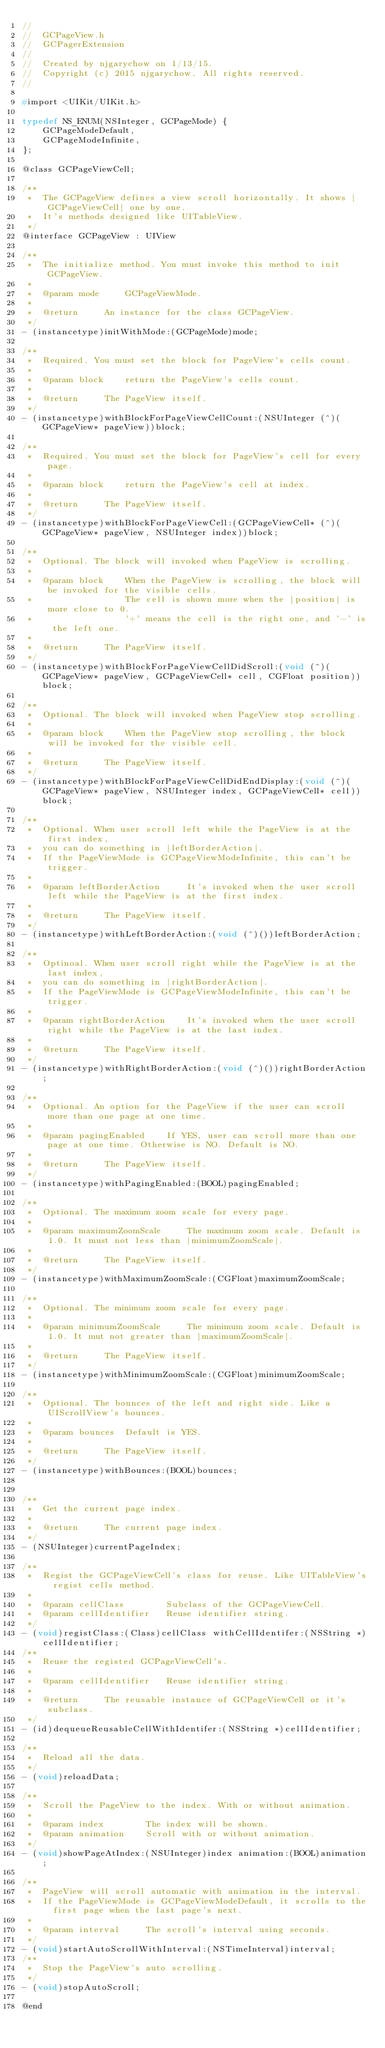<code> <loc_0><loc_0><loc_500><loc_500><_C_>//
//  GCPageView.h
//  GCPagerExtension
//
//  Created by njgarychow on 1/13/15.
//  Copyright (c) 2015 njgarychow. All rights reserved.
//

#import <UIKit/UIKit.h>

typedef NS_ENUM(NSInteger, GCPageMode) {
    GCPageModeDefault,
    GCPageModeInfinite,
};

@class GCPageViewCell;

/**
 *  The GCPageView defines a view scroll horizontally. It shows |GCPageViewCell| one by one. 
 *  It's methods designed like UITableView.
 */
@interface GCPageView : UIView

/**
 *  The initialize method. You must invoke this method to init GCPageView.
 *
 *  @param mode     GCPageViewMode.
 *
 *  @return     An instance for the class GCPageView.
 */
- (instancetype)initWithMode:(GCPageMode)mode;

/**
 *  Required. You must set the block for PageView's cells count.
 *
 *  @param block    return the PageView's cells count.
 *
 *  @return     The PageView itself.
 */
- (instancetype)withBlockForPageViewCellCount:(NSUInteger (^)(GCPageView* pageView))block;

/**
 *  Required. You must set the block for PageView's cell for every page.
 *
 *  @param block    return the PageView's cell at index.
 *
 *  @return     The PageView itself.
 */
- (instancetype)withBlockForPageViewCell:(GCPageViewCell* (^)(GCPageView* pageView, NSUInteger index))block;

/**
 *  Optional. The block will invoked when PageView is scrolling.
 *
 *  @param block    When the PageView is scrolling, the block will be invoked for the visible cells.
 *                  The cell is shown more when the |position| is more close to 0.
 *                  '+' means the cell is the right one, and '-' is the left one.
 *
 *  @return     The PageView itself.
 */
- (instancetype)withBlockForPageViewCellDidScroll:(void (^)(GCPageView* pageView, GCPageViewCell* cell, CGFloat position))block;

/**
 *  Optional. The block will invoked when PageView stop scrolling.
 *
 *  @param block    When the PageView stop scrolling, the block will be invoked for the visible cell.
 *
 *  @return     The PageView itself.
 */
- (instancetype)withBlockForPageViewCellDidEndDisplay:(void (^)(GCPageView* pageView, NSUInteger index, GCPageViewCell* cell))block;

/**
 *  Optional. When user scroll left while the PageView is at the first index, 
 *  you can do something in |leftBorderAction|. 
 *  If the PageViewMode is GCPageViewModeInfinite, this can't be trigger.
 *
 *  @param leftBorderAction     It's invoked when the user scroll left while the PageView is at the first index.
 *
 *  @return     The PageView itself.
 */
- (instancetype)withLeftBorderAction:(void (^)())leftBorderAction;

/**
 *  Optinoal. When user scroll right while the PageView is at the last index,
 *  you can do something in |rightBorderAction|.
 *  If the PageViewMode is GCPageViewModeInfinite, this can't be trigger.
 *
 *  @param rightBorderAction    It's invoked when the user scroll right while the PageView is at the last index.
 *
 *  @return     The PageView itself.
 */
- (instancetype)withRightBorderAction:(void (^)())rightBorderAction;

/**
 *  Optional. An option for the PageView if the user can scroll more than one page at one time.
 *
 *  @param pagingEnabled    If YES, user can scroll more than one page at one time. Otherwise is NO. Default is NO.
 *
 *  @return     The PageView itself.
 */
- (instancetype)withPagingEnabled:(BOOL)pagingEnabled;

/**
 *  Optional. The maximum zoom scale for every page.
 *
 *  @param maximumZoomScale     The maximum zoom scale. Default is 1.0. It must not less than |minimumZoomScale|.
 *
 *  @return     The PageView itself.
 */
- (instancetype)withMaximumZoomScale:(CGFloat)maximumZoomScale;

/**
 *  Optional. The minimum zoom scale for every page.
 *
 *  @param minimumZoomScale     The minimum zoom scale. Default is 1.0. It mut not greater than |maximumZoomScale|.
 *
 *  @return     The PageView itself.
 */
- (instancetype)withMinimumZoomScale:(CGFloat)minimumZoomScale;

/**
 *  Optional. The bounces of the left and right side. Like a UIScrollView's bounces.
 *
 *  @param bounces  Default is YES.
 *
 *  @return     The PageView itself.
 */
- (instancetype)withBounces:(BOOL)bounces;


/**
 *  Get the current page index.
 *
 *  @return     The current page index.
 */
- (NSUInteger)currentPageIndex;

/**
 *  Regist the GCPageViewCell's class for reuse. Like UITableView's regist cells method.
 *
 *  @param cellClass        Subclass of the GCPageViewCell.
 *  @param cellIdentifier   Reuse identifier string.
 */
- (void)registClass:(Class)cellClass withCellIdentifer:(NSString *)cellIdentifier;
/**
 *  Reuse the registed GCPageViewCell's.
 *
 *  @param cellIdentifier   Reuse identifier string.
 *
 *  @return     The reusable instance of GCPageViewCell or it's subclass.
 */
- (id)dequeueReusableCellWithIdentifer:(NSString *)cellIdentifier;

/**
 *  Reload all the data.
 */
- (void)reloadData;

/**
 *  Scroll the PageView to the index. With or without animation.
 *
 *  @param index        The index will be shown.
 *  @param animation    Scroll with or without animation.
 */
- (void)showPageAtIndex:(NSUInteger)index animation:(BOOL)animation;

/**
 *  PageView will scroll automatic with animation in the interval.
 *  If the PageViewMode is GCPageViewModeDefault, it scrolls to the first page when the last page's next.
 *
 *  @param interval     The scroll's interval using seconds.
 */
- (void)startAutoScrollWithInterval:(NSTimeInterval)interval;
/**
 *  Stop the PageView's auto scrolling.
 */
- (void)stopAutoScroll;

@end
</code> 